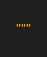<code> <loc_0><loc_0><loc_500><loc_500><_Python_>"""</code> 